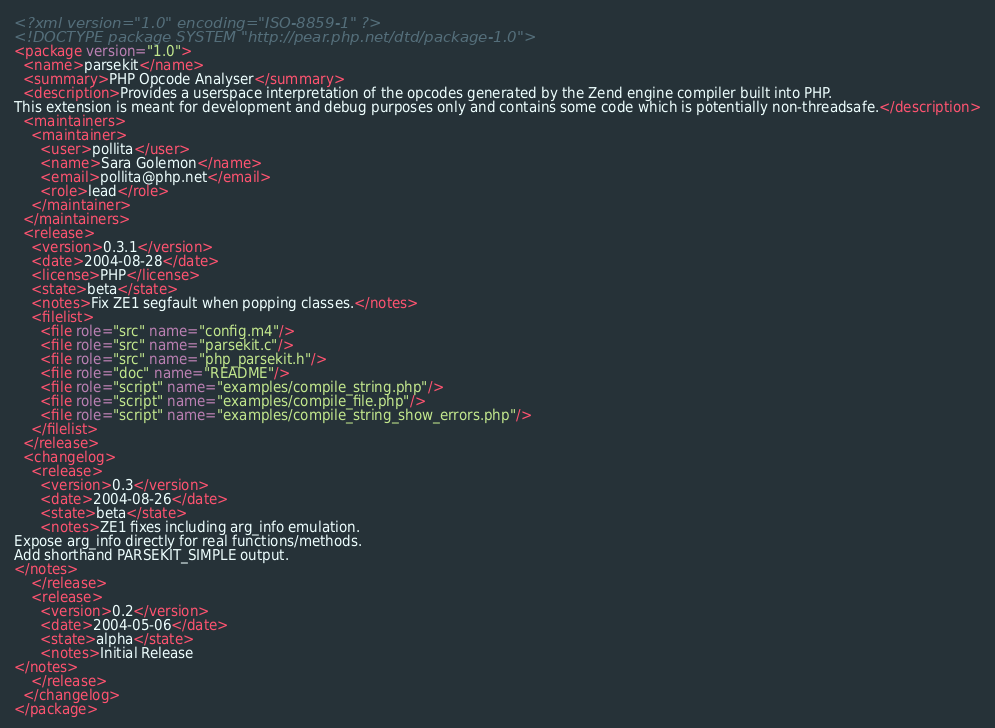Convert code to text. <code><loc_0><loc_0><loc_500><loc_500><_XML_><?xml version="1.0" encoding="ISO-8859-1" ?>
<!DOCTYPE package SYSTEM "http://pear.php.net/dtd/package-1.0">
<package version="1.0">
  <name>parsekit</name>
  <summary>PHP Opcode Analyser</summary>
  <description>Provides a userspace interpretation of the opcodes generated by the Zend engine compiler built into PHP.
This extension is meant for development and debug purposes only and contains some code which is potentially non-threadsafe.</description>
  <maintainers>
    <maintainer>
      <user>pollita</user>
      <name>Sara Golemon</name>
      <email>pollita@php.net</email>
      <role>lead</role>
    </maintainer>
  </maintainers>
  <release>
    <version>0.3.1</version>
    <date>2004-08-28</date>
    <license>PHP</license>
    <state>beta</state>
    <notes>Fix ZE1 segfault when popping classes.</notes>
    <filelist>
      <file role="src" name="config.m4"/>
      <file role="src" name="parsekit.c"/>
      <file role="src" name="php_parsekit.h"/>
      <file role="doc" name="README"/>
      <file role="script" name="examples/compile_string.php"/>
      <file role="script" name="examples/compile_file.php"/>
      <file role="script" name="examples/compile_string_show_errors.php"/>
    </filelist>
  </release>
  <changelog>
    <release>
      <version>0.3</version>
      <date>2004-08-26</date>
      <state>beta</state>
      <notes>ZE1 fixes including arg_info emulation.
Expose arg_info directly for real functions/methods.
Add shorthand PARSEKIT_SIMPLE output.
</notes>
    </release>
    <release>
      <version>0.2</version>
      <date>2004-05-06</date>
      <state>alpha</state>
      <notes>Initial Release
</notes>
    </release>
  </changelog>
</package>
</code> 